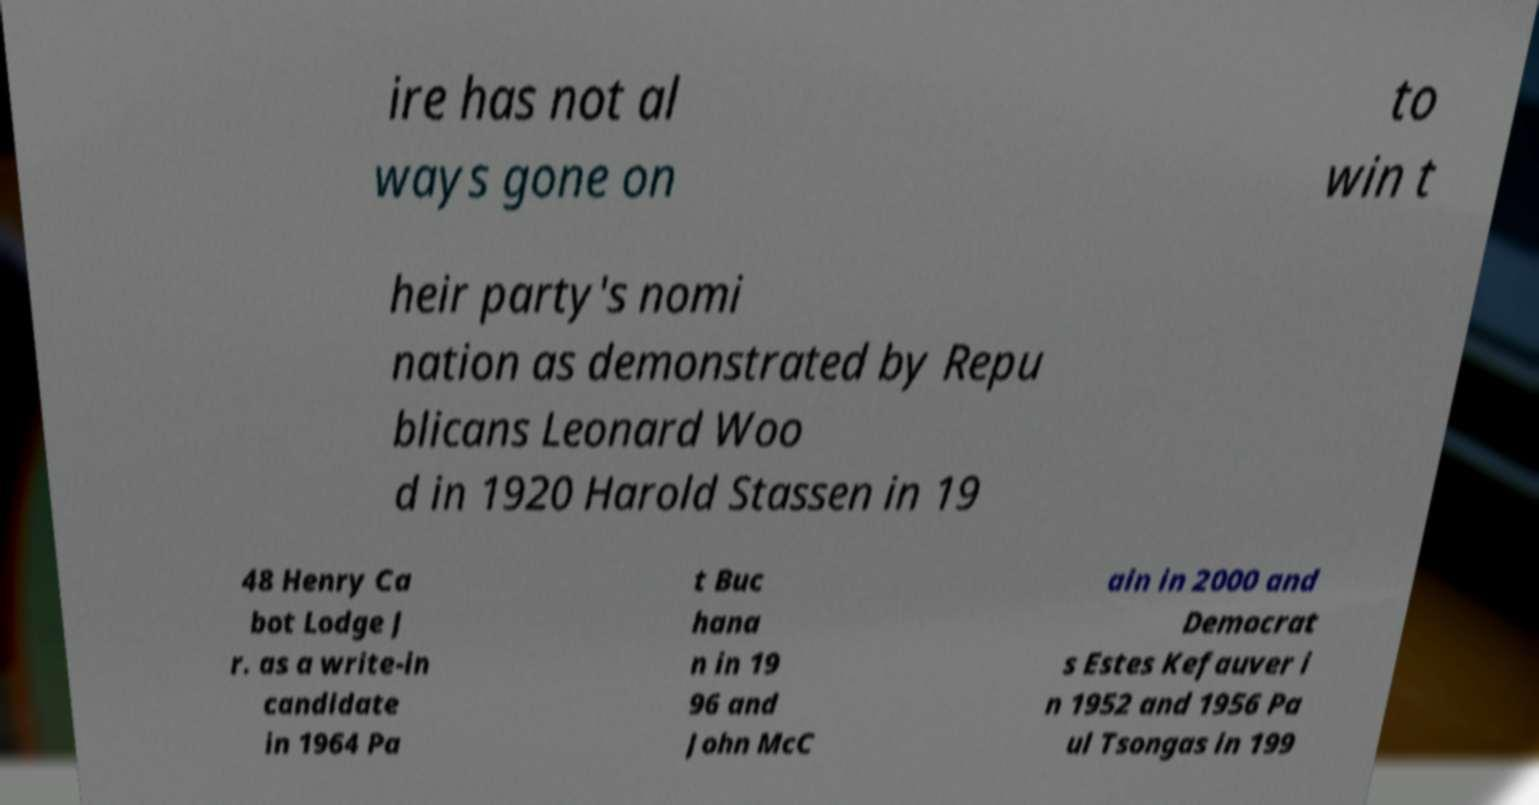Please identify and transcribe the text found in this image. ire has not al ways gone on to win t heir party's nomi nation as demonstrated by Repu blicans Leonard Woo d in 1920 Harold Stassen in 19 48 Henry Ca bot Lodge J r. as a write-in candidate in 1964 Pa t Buc hana n in 19 96 and John McC ain in 2000 and Democrat s Estes Kefauver i n 1952 and 1956 Pa ul Tsongas in 199 